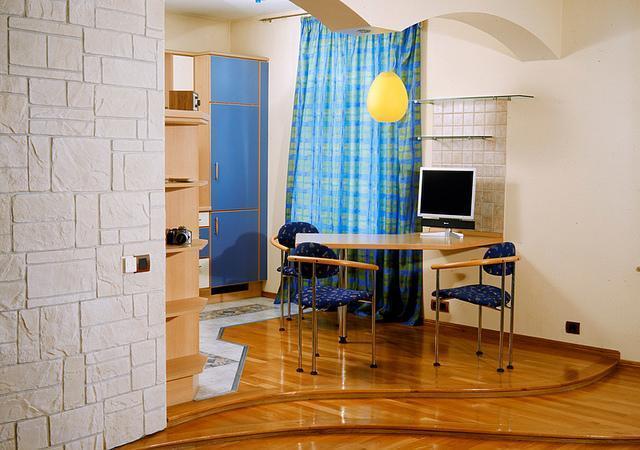How many chairs are in the picture?
Give a very brief answer. 2. How many men have no shirts on?
Give a very brief answer. 0. 